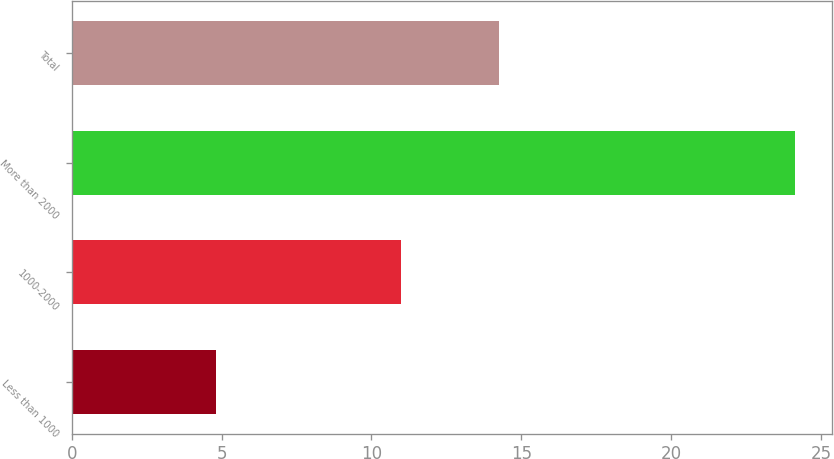Convert chart to OTSL. <chart><loc_0><loc_0><loc_500><loc_500><bar_chart><fcel>Less than 1000<fcel>1000-2000<fcel>More than 2000<fcel>Total<nl><fcel>4.8<fcel>10.99<fcel>24.15<fcel>14.24<nl></chart> 